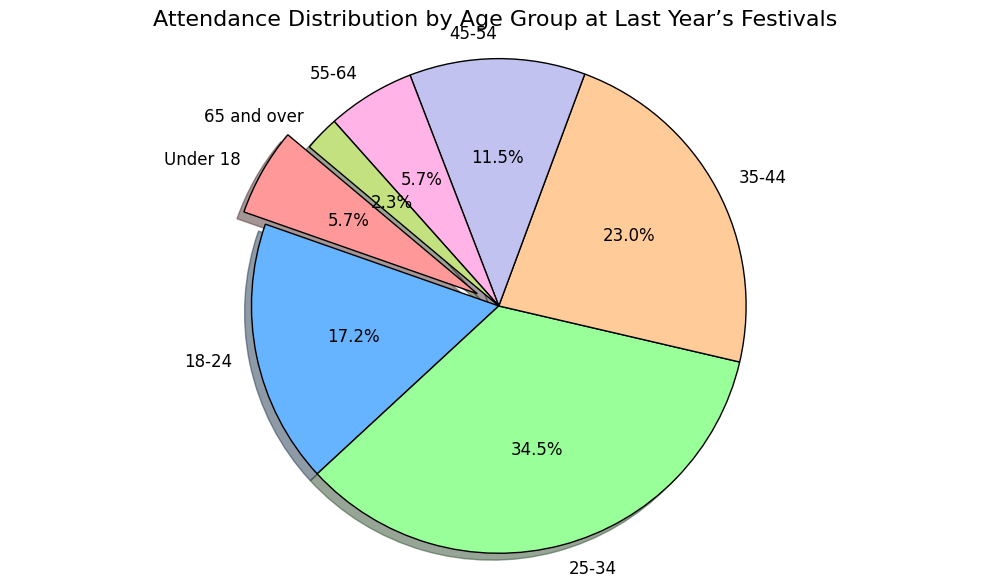What age group had the highest attendance? By looking at the figure, we can see which slice of the pie chart is the largest. This represents the age group with the highest attendance. The largest slice corresponds to the 25-34 age group.
Answer: 25-34 What is the percentage of attendees under 18? To determine the percentage, look at the slice labeled "Under 18". The pie chart provides the percentage directly in the slice as 9.1%.
Answer: 9.1% Which age group had a lower attendance: 45-54 or 55-64? Compare the sizes of the pie slices for age groups 45-54 and 55-64. The slice for 55-64 is smaller.
Answer: 55-64 What is the combined percentage of attendees aged 18-24 and 25-34? Add the percentages of the 18-24 and 25-34 slices. The chart shows 27.3% for 18-24 and 54.5% for 25-34, so the total is 27.3% + 54.5% = 81.8%.
Answer: 81.8% What percentage of attendees were 35-44 years old? Identify the 35-44 slice of the pie chart and read the percentage value, which is provided within the slice as 36.4%.
Answer: 36.4% Which age groups have equal attendance? Compare the sizes and percentages of each pie slice to see if any two are the same. Both the "Under 18" and "55-64" slices have equal attendance of 9.1%.
Answer: Under 18 and 55-64 By how much does the attendance of age group 25-34 exceed that of 45-54? First, find the percentages for 25-34 (54.5%) and 45-54 (18.2%). Then subtract the smaller from the larger: 54.5% - 18.2% = 36.3%.
Answer: 36.3% Which age group shows the least attendance, and what is the percentage? Look at all the slices and find the smallest one. The "65 and over" slice is the smallest with a percentage of 3.6%.
Answer: 65 and over, 3.6% 